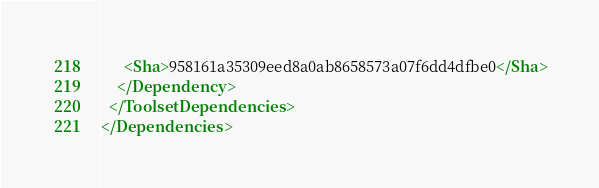Convert code to text. <code><loc_0><loc_0><loc_500><loc_500><_XML_>      <Sha>958161a35309eed8a0ab8658573a07f6dd4dfbe0</Sha>
    </Dependency>
  </ToolsetDependencies>
</Dependencies>
</code> 